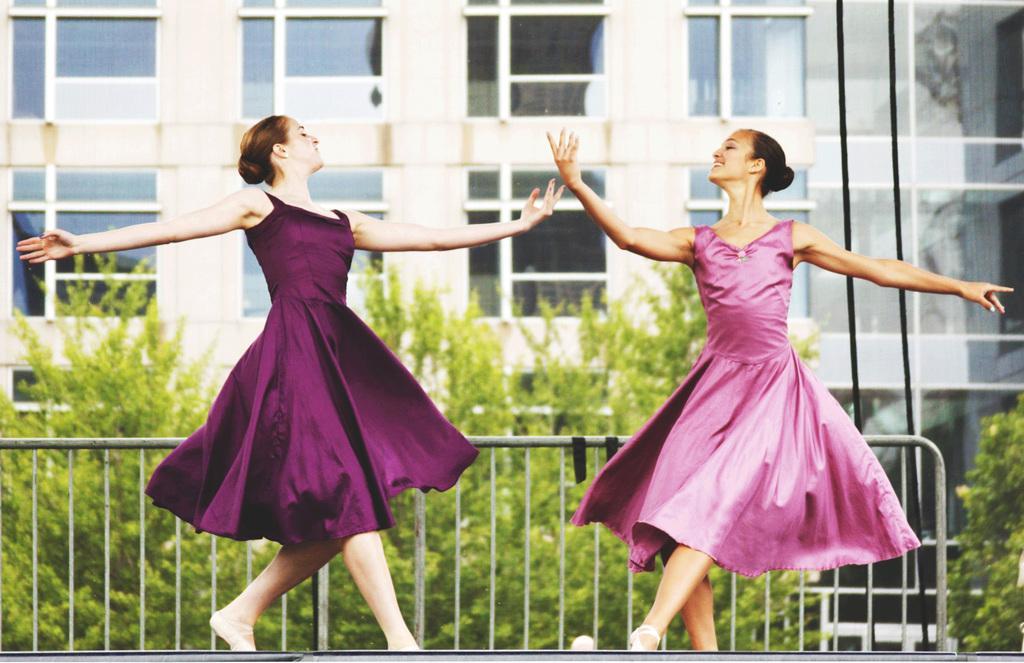In one or two sentences, can you explain what this image depicts? We can see two women are dancing. In the background there is a fence,trees,building,glass doors and on the right we can see two wires. 